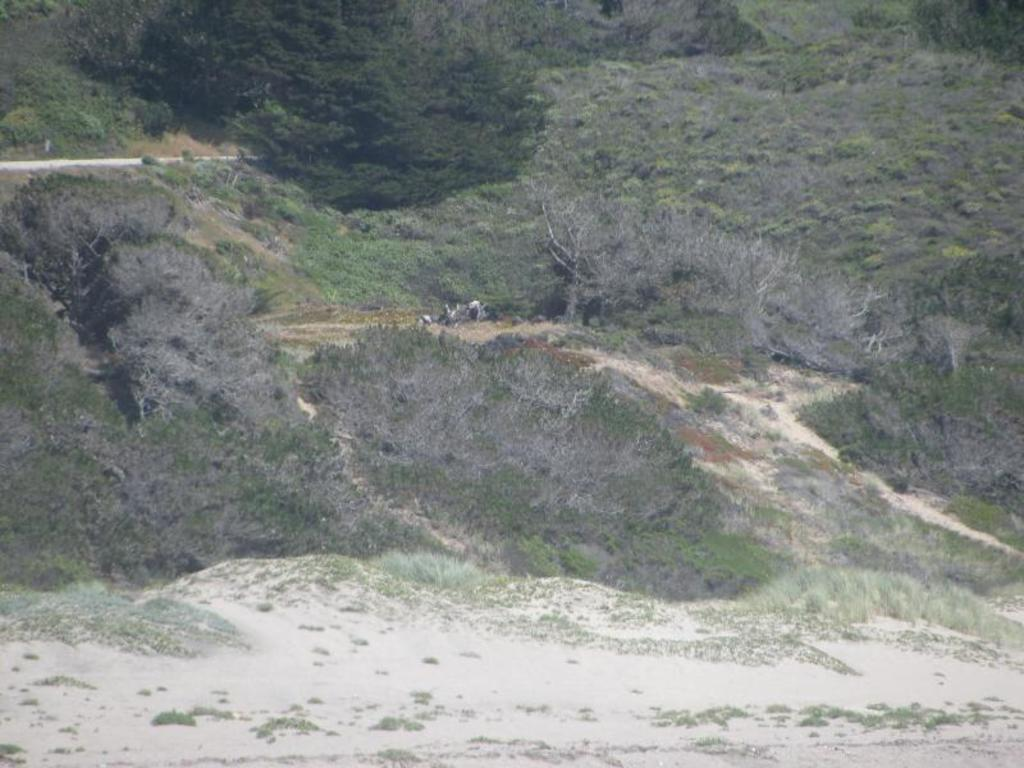What type of vegetation is present in the image? There are many trees and plants in the image. Can you describe the road in the image? There is a road on the left side of the image. How many rings can be seen on the trees in the image? There are no rings visible on the trees in the image. What is the process of digestion like for the plants in the image? The image does not provide information about the digestion process of the plants. 